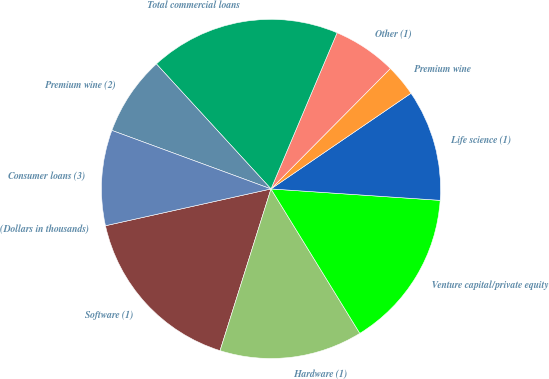<chart> <loc_0><loc_0><loc_500><loc_500><pie_chart><fcel>(Dollars in thousands)<fcel>Software (1)<fcel>Hardware (1)<fcel>Venture capital/private equity<fcel>Life science (1)<fcel>Premium wine<fcel>Other (1)<fcel>Total commercial loans<fcel>Premium wine (2)<fcel>Consumer loans (3)<nl><fcel>0.0%<fcel>16.66%<fcel>13.63%<fcel>15.15%<fcel>10.61%<fcel>3.03%<fcel>6.06%<fcel>18.18%<fcel>7.58%<fcel>9.09%<nl></chart> 